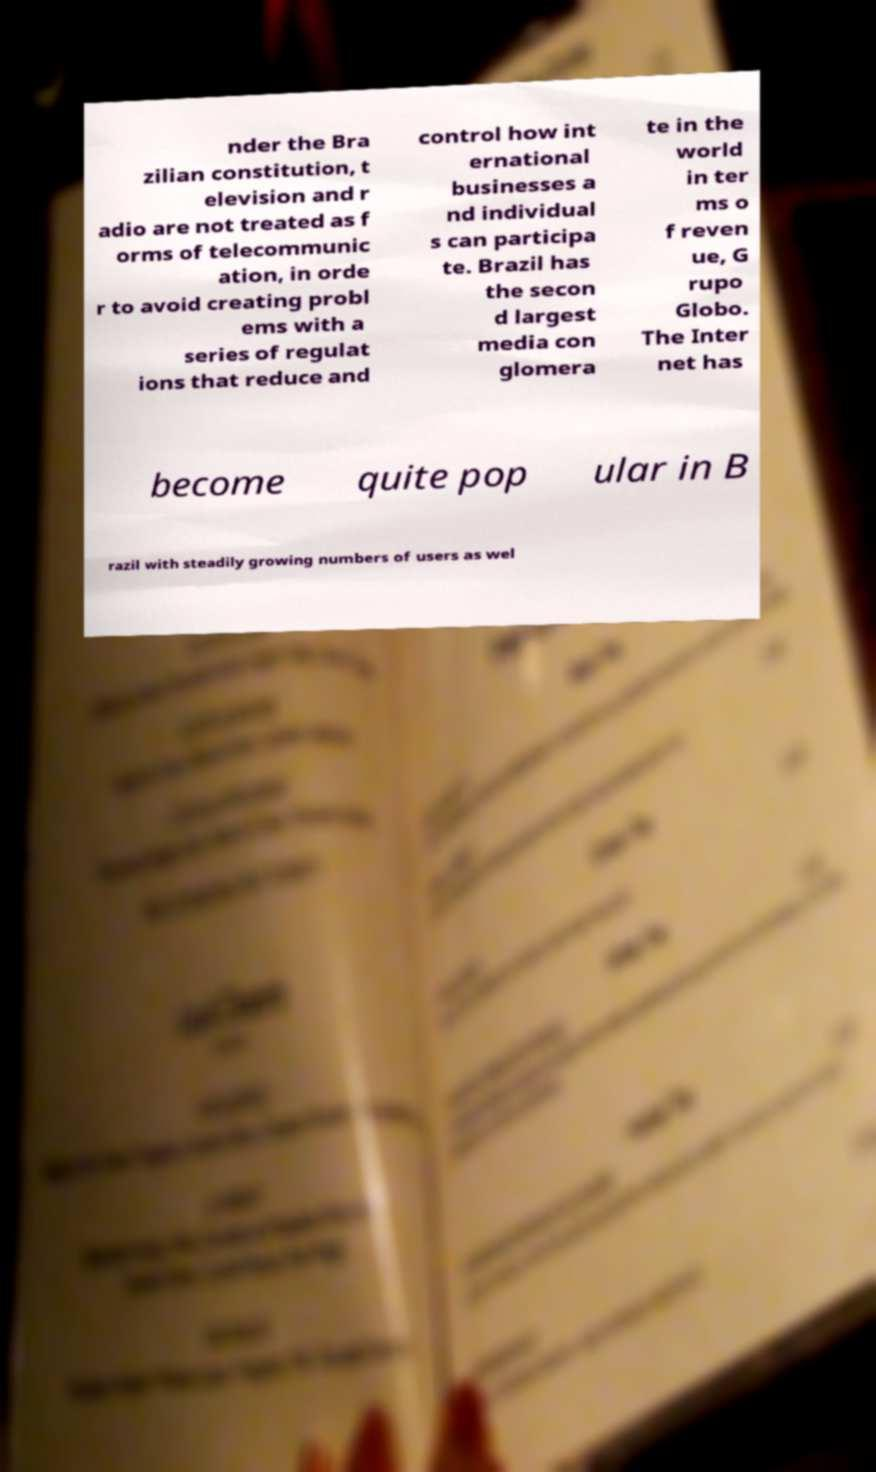What messages or text are displayed in this image? I need them in a readable, typed format. nder the Bra zilian constitution, t elevision and r adio are not treated as f orms of telecommunic ation, in orde r to avoid creating probl ems with a series of regulat ions that reduce and control how int ernational businesses a nd individual s can participa te. Brazil has the secon d largest media con glomera te in the world in ter ms o f reven ue, G rupo Globo. The Inter net has become quite pop ular in B razil with steadily growing numbers of users as wel 